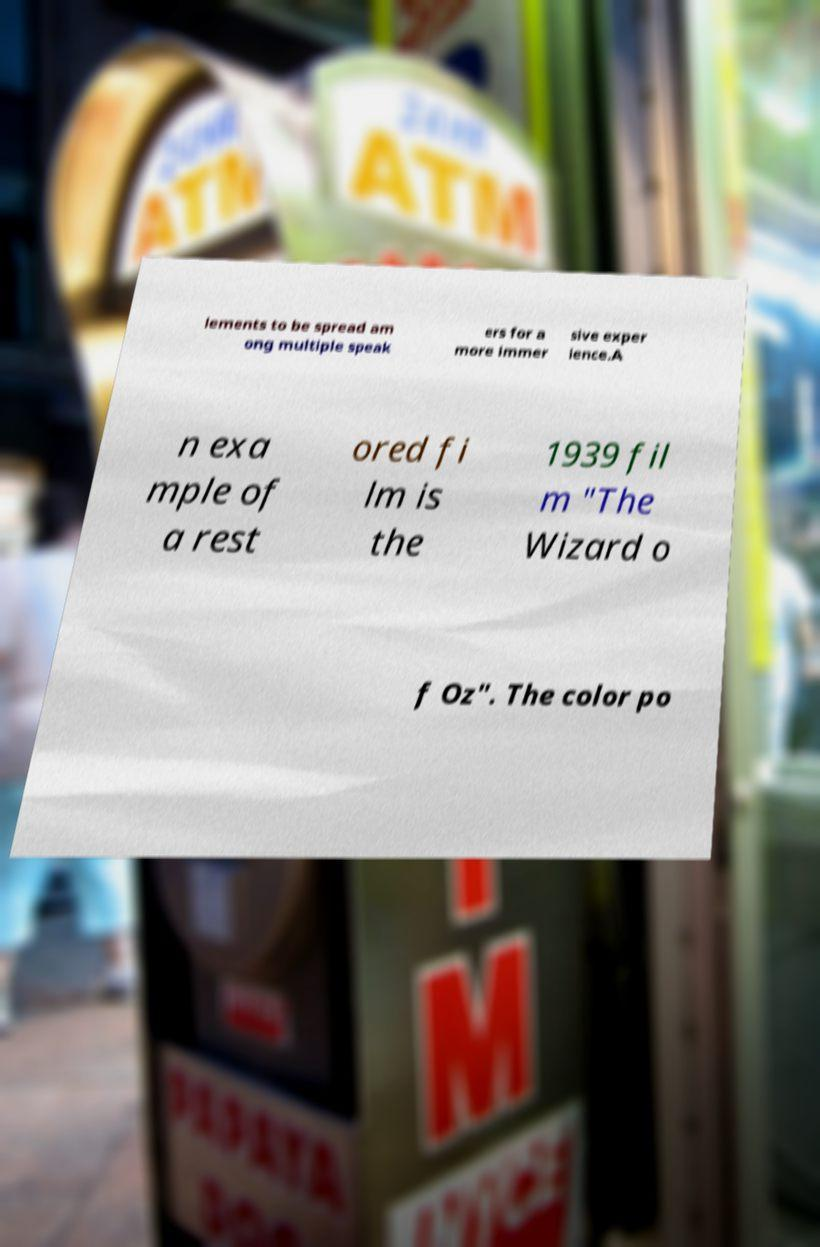Please identify and transcribe the text found in this image. lements to be spread am ong multiple speak ers for a more immer sive exper ience.A n exa mple of a rest ored fi lm is the 1939 fil m "The Wizard o f Oz". The color po 